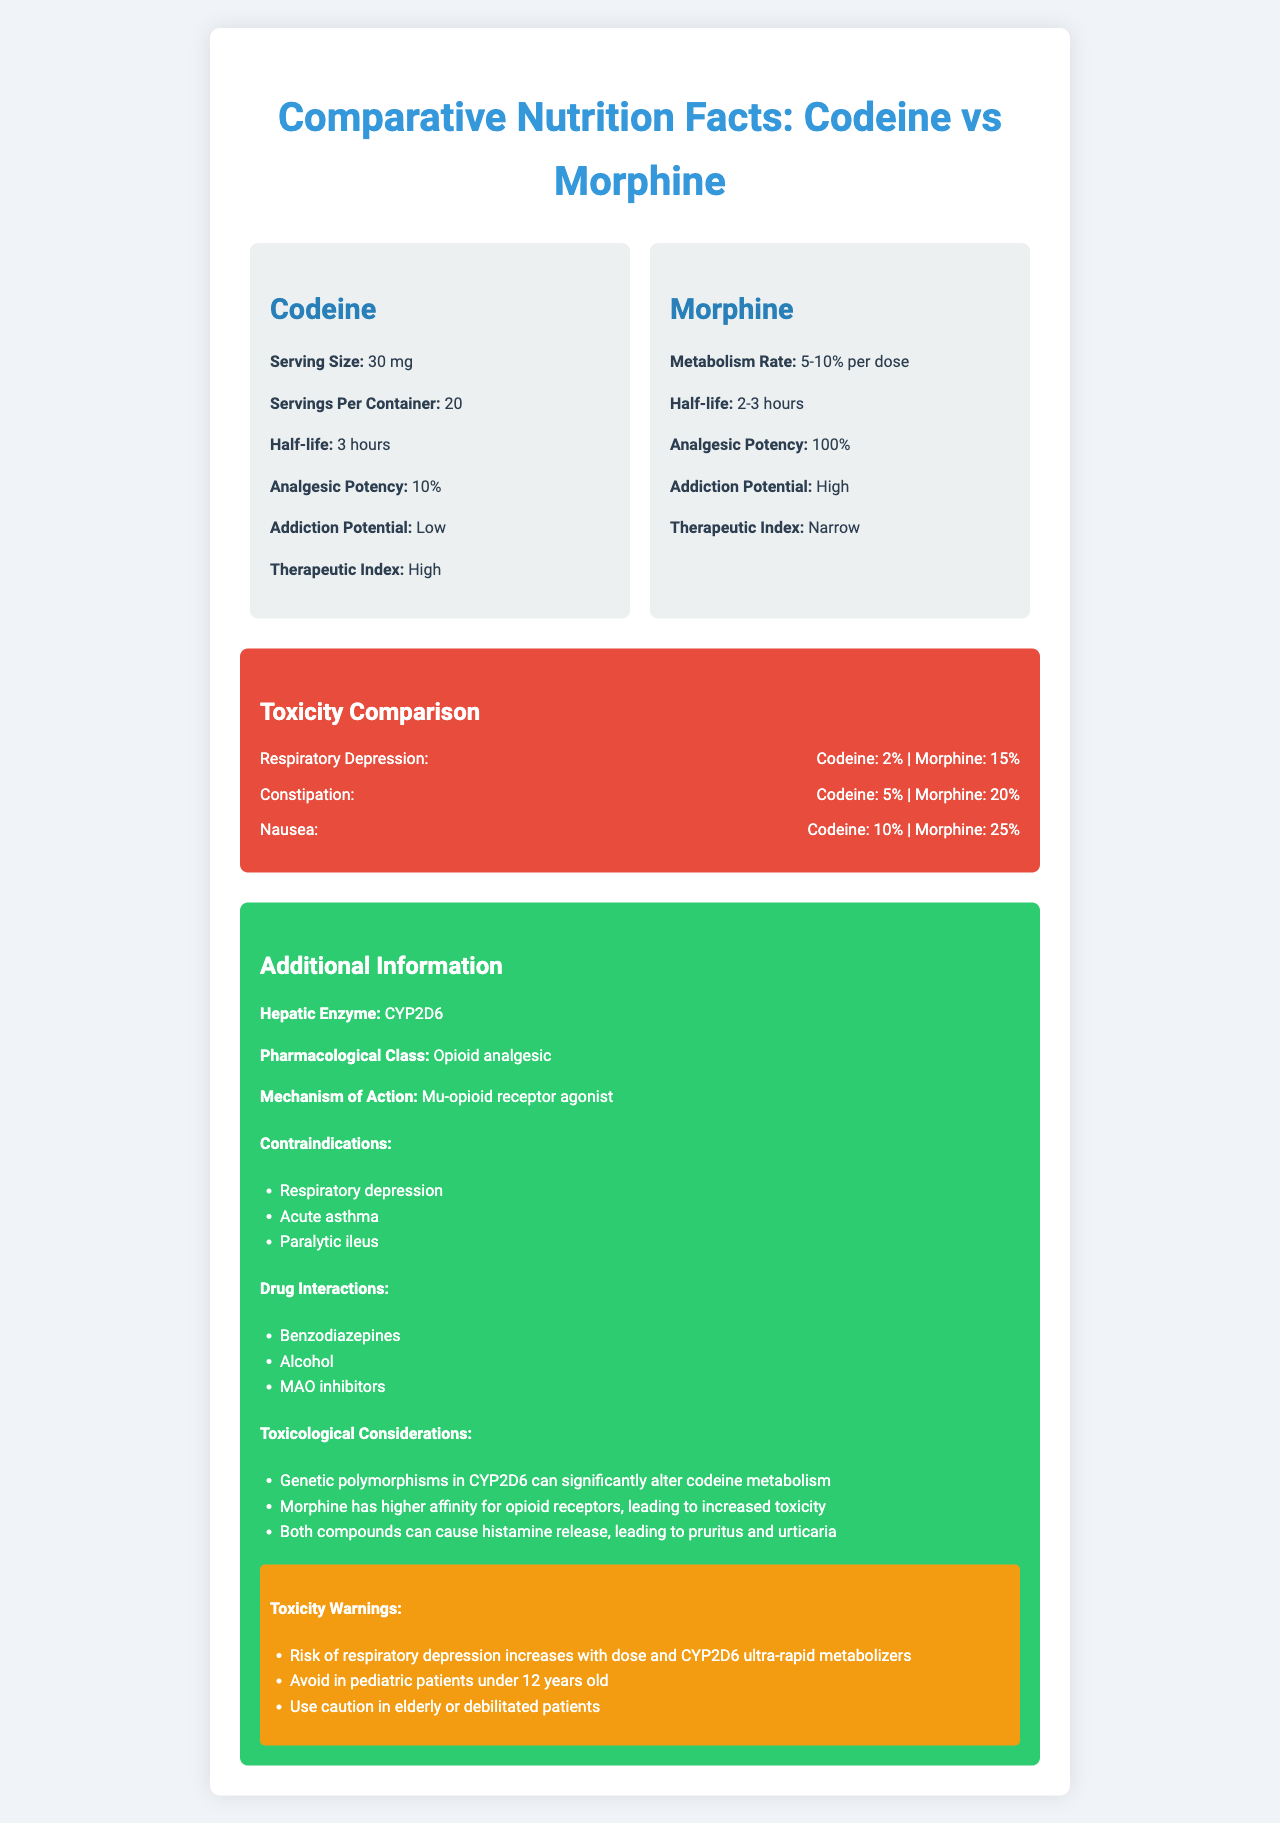is the addiction potential of morphine higher than codeine? The document indicates that codeine has "Low" addiction potential, while morphine's addiction potential is labeled "High."
Answer: Yes what is the half-life of codeine? The half-life of codeine is listed under the 'drug-info' section for the parent drug (Codeine).
Answer: 3 hours which opioid has a higher frequency of causing nausea? A. Codeine B. Morphine The document shows that codeine causes nausea with a frequency of 10%, whereas morphine causes it with a frequency of 25%. Therefore, morphine has a higher frequency of causing nausea.
Answer: B how much codeine gets metabolized to morphine per dose? The metabolism rate mentioned in the document is "5-10% per dose."
Answer: 5-10% is codeine or morphine more potent as an analgesic? The analgesic potency for codeine is 10%, while for morphine, it is 100%, making morphine significantly more potent.
Answer: Morphine what is one of the contraindications listed for both codeine and morphine? Respiratory depression is listed as a contraindication for both drugs in the document.
Answer: Respiratory depression which hepatic enzyme is involved in codeine metabolism? The document states that the hepatic enzyme involved is CYP2D6.
Answer: CYP2D6 what is the serving size for both codeine and morphine? The serving size listed is 30 mg for both codeine and morphine.
Answer: 30 mg name a drug interaction that both codeine and morphine share. Alcohol is listed under drug interactions for both codeine and morphine in the document.
Answer: Alcohol what is the therapeutic index of codeine? The document specifies that the therapeutic index of codeine is "High."
Answer: High which has a narrower therapeutic index, codeine or morphine? The therapeutic index for codeine is listed as "High," while for morphine, it is "Narrow."
Answer: Morphine does morphine have a longer or shorter half-life than codeine? Morphine has a half-life of 2-3 hours, while codeine has a half-life of 3 hours, making morphine's half-life either shorter or the same depending on the exact half-life within the range.
Answer: Shorter or the same describe the mechanism of action for both codeine and morphine. Both codeine and morphine act through the same mechanism of action: they are mu-opioid receptor agonists.
Answer: Mu-opioid receptor agonist summarize the main differences in toxicity profiles between codeine and morphine. The document shows that morphine has significantly higher toxicity profiles than codeine in various aspects, including respiratory depression (15% vs. 2%), constipation (20% vs. 5%), and nausea (25% vs. 10%). Morphine also has a higher addiction potential and narrower therapeutic index.
Answer: Morphine has higher toxicity what is the main pharmacological class for both drugs? The document states that the pharmacological class for both codeine and morphine is "Opioid analgesic."
Answer: Opioid analgesic can it be determined what effects CYP2D6 polymorphisms have? The document mentions that genetic polymorphisms in CYP2D6 can significantly alter codeine metabolism but does not provide specific effects of different polymorphisms.
Answer: No, Not enough information 